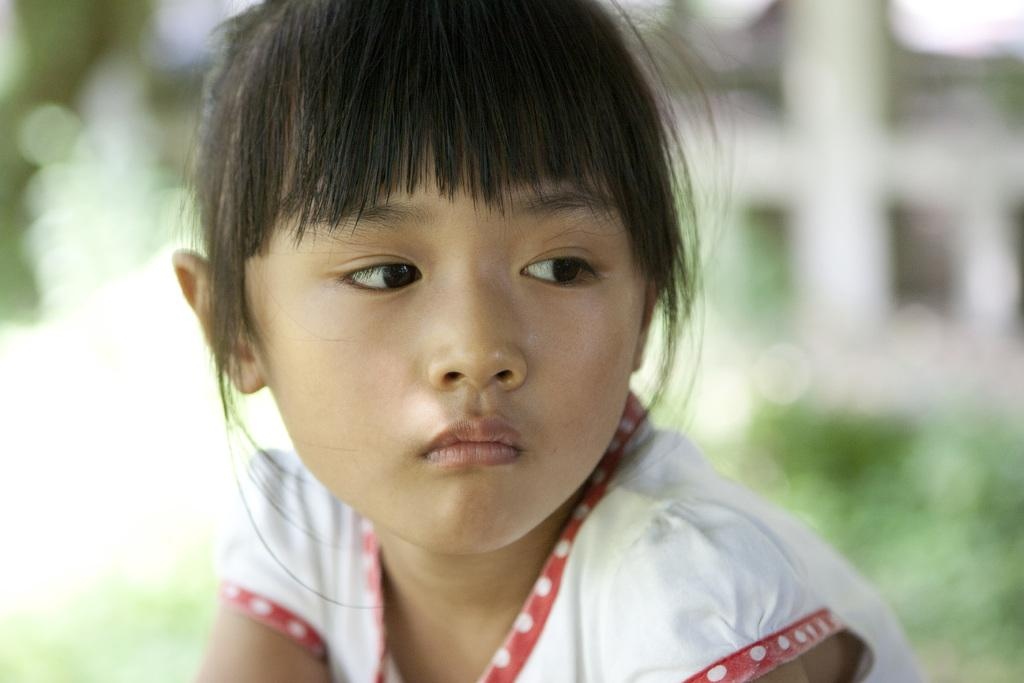Who is the main subject in the image? There is a girl in the image. What is the girl wearing? The girl is wearing a white and red color dress. Can you describe the background of the image? The background of the image is blurred. What type of vacation is the girl planning based on the image? There is no information about a vacation in the image, so it cannot be determined from the image. 